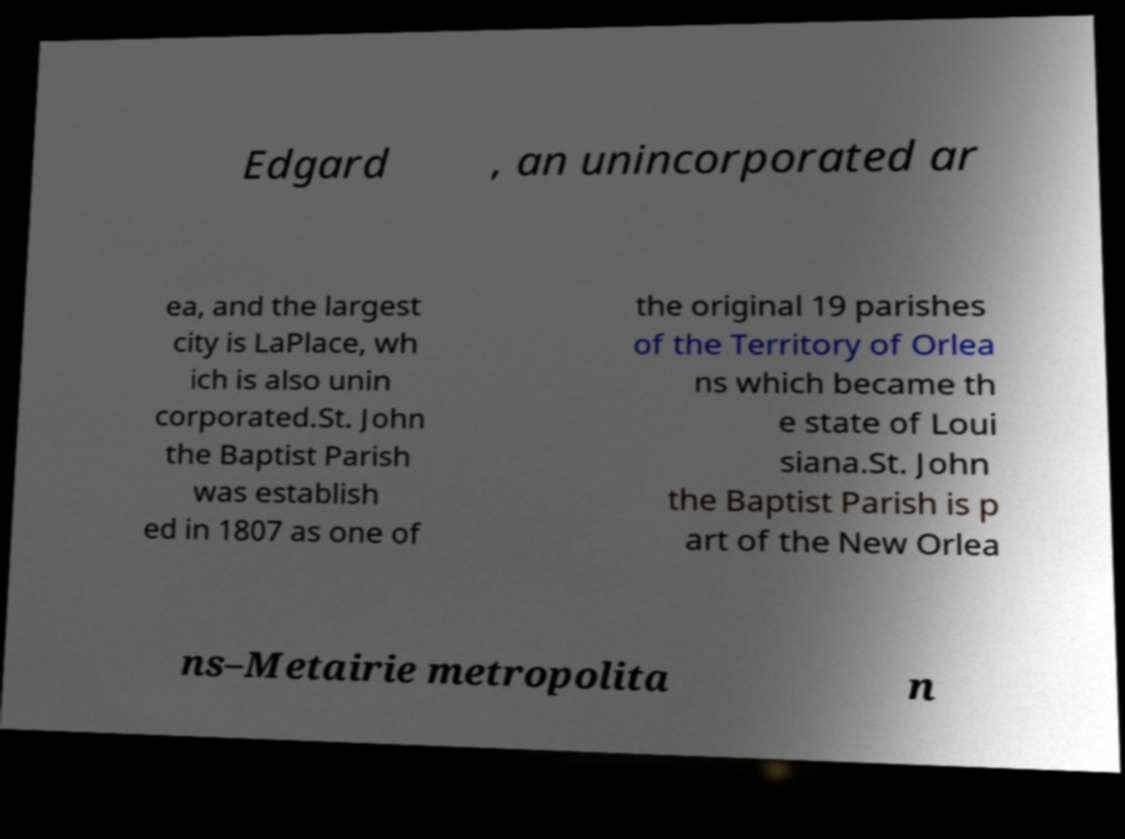Please read and relay the text visible in this image. What does it say? Edgard , an unincorporated ar ea, and the largest city is LaPlace, wh ich is also unin corporated.St. John the Baptist Parish was establish ed in 1807 as one of the original 19 parishes of the Territory of Orlea ns which became th e state of Loui siana.St. John the Baptist Parish is p art of the New Orlea ns–Metairie metropolita n 